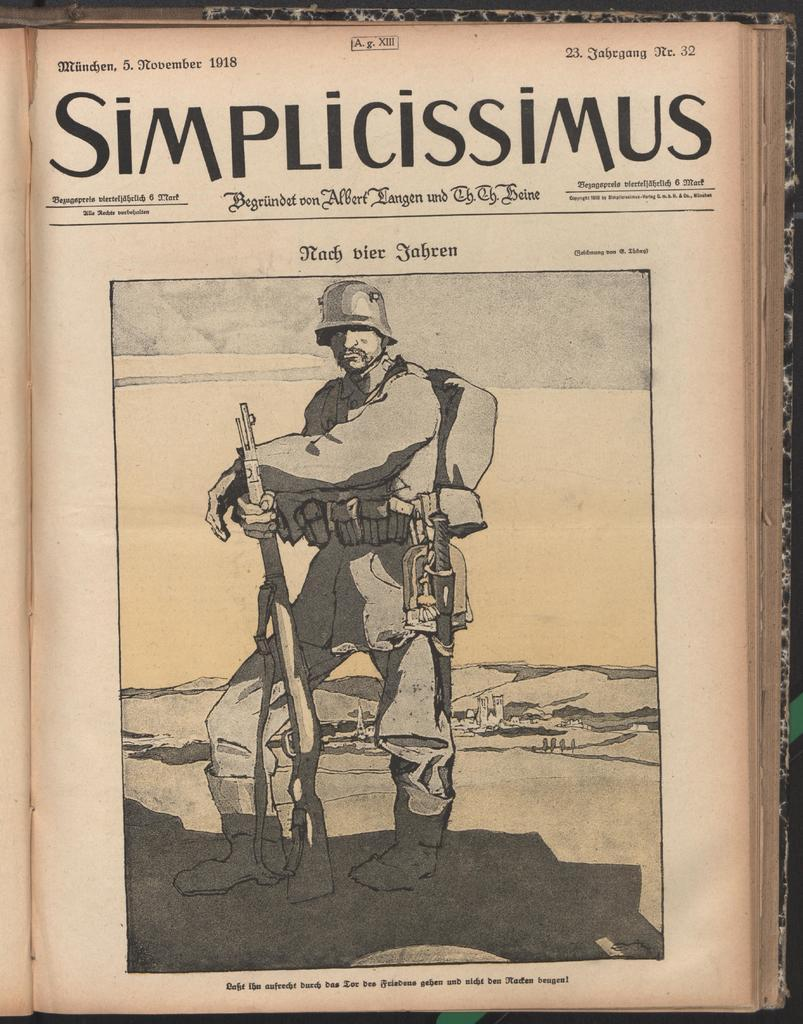What is the main subject of the image? The main subject of the image is a picture of a person. Can you describe any additional elements in the image? Yes, there are texts written on a paper of a book in the image. What is the price of the book in the image? There is no information about the price of the book in the image. 